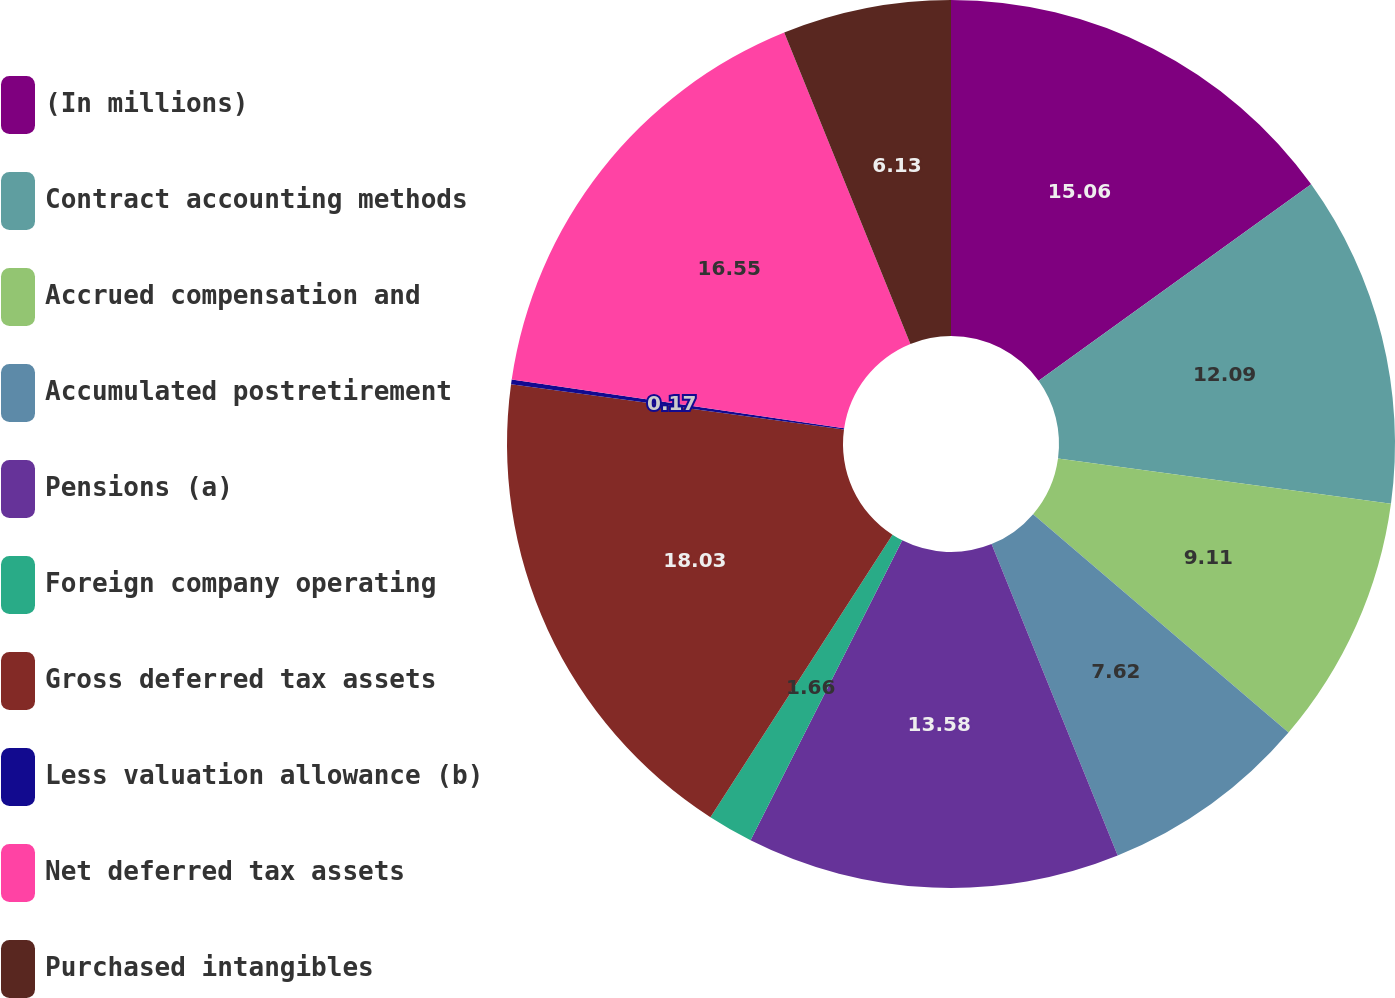<chart> <loc_0><loc_0><loc_500><loc_500><pie_chart><fcel>(In millions)<fcel>Contract accounting methods<fcel>Accrued compensation and<fcel>Accumulated postretirement<fcel>Pensions (a)<fcel>Foreign company operating<fcel>Gross deferred tax assets<fcel>Less valuation allowance (b)<fcel>Net deferred tax assets<fcel>Purchased intangibles<nl><fcel>15.06%<fcel>12.09%<fcel>9.11%<fcel>7.62%<fcel>13.58%<fcel>1.66%<fcel>18.04%<fcel>0.17%<fcel>16.55%<fcel>6.13%<nl></chart> 